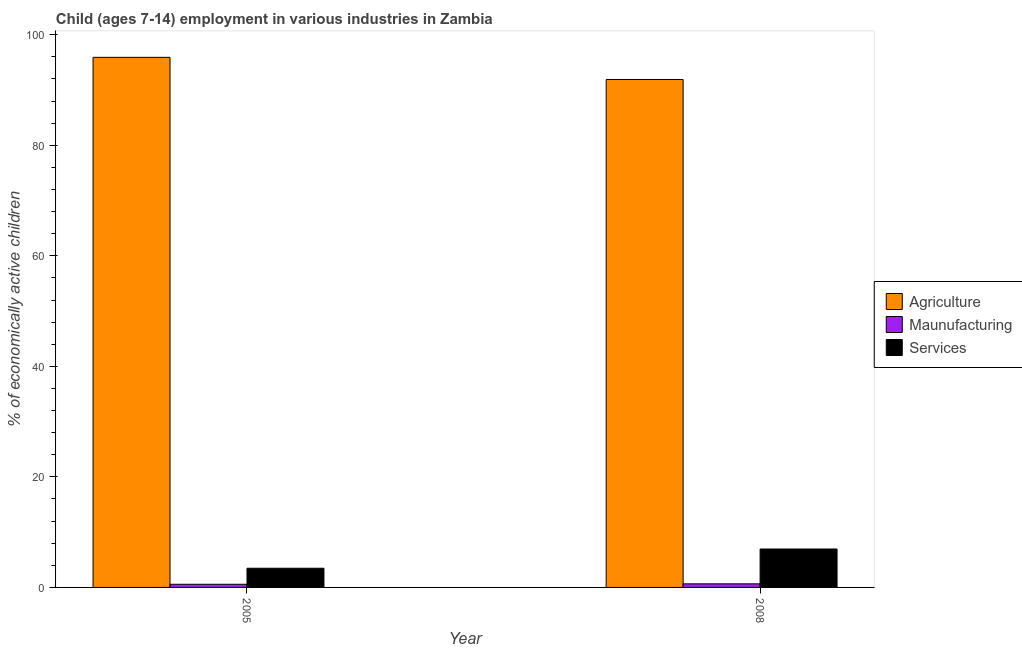How many groups of bars are there?
Offer a terse response. 2. Are the number of bars on each tick of the X-axis equal?
Offer a very short reply. Yes. How many bars are there on the 1st tick from the left?
Keep it short and to the point. 3. How many bars are there on the 2nd tick from the right?
Your answer should be very brief. 3. In how many cases, is the number of bars for a given year not equal to the number of legend labels?
Give a very brief answer. 0. What is the percentage of economically active children in agriculture in 2008?
Your answer should be very brief. 91.9. Across all years, what is the maximum percentage of economically active children in services?
Give a very brief answer. 6.95. Across all years, what is the minimum percentage of economically active children in manufacturing?
Provide a short and direct response. 0.57. In which year was the percentage of economically active children in manufacturing maximum?
Offer a terse response. 2008. In which year was the percentage of economically active children in manufacturing minimum?
Ensure brevity in your answer.  2005. What is the total percentage of economically active children in services in the graph?
Your answer should be very brief. 10.42. What is the difference between the percentage of economically active children in manufacturing in 2005 and that in 2008?
Your response must be concise. -0.08. What is the difference between the percentage of economically active children in services in 2008 and the percentage of economically active children in manufacturing in 2005?
Offer a very short reply. 3.48. What is the average percentage of economically active children in agriculture per year?
Your response must be concise. 93.91. What is the ratio of the percentage of economically active children in services in 2005 to that in 2008?
Provide a succinct answer. 0.5. In how many years, is the percentage of economically active children in services greater than the average percentage of economically active children in services taken over all years?
Provide a short and direct response. 1. What does the 3rd bar from the left in 2008 represents?
Provide a succinct answer. Services. What does the 2nd bar from the right in 2008 represents?
Your response must be concise. Maunufacturing. Does the graph contain any zero values?
Give a very brief answer. No. Does the graph contain grids?
Your answer should be compact. No. Where does the legend appear in the graph?
Your answer should be very brief. Center right. How many legend labels are there?
Keep it short and to the point. 3. What is the title of the graph?
Offer a very short reply. Child (ages 7-14) employment in various industries in Zambia. Does "Methane" appear as one of the legend labels in the graph?
Give a very brief answer. No. What is the label or title of the X-axis?
Make the answer very short. Year. What is the label or title of the Y-axis?
Make the answer very short. % of economically active children. What is the % of economically active children of Agriculture in 2005?
Provide a short and direct response. 95.91. What is the % of economically active children of Maunufacturing in 2005?
Provide a succinct answer. 0.57. What is the % of economically active children in Services in 2005?
Give a very brief answer. 3.47. What is the % of economically active children of Agriculture in 2008?
Your answer should be compact. 91.9. What is the % of economically active children in Maunufacturing in 2008?
Provide a succinct answer. 0.65. What is the % of economically active children of Services in 2008?
Offer a very short reply. 6.95. Across all years, what is the maximum % of economically active children in Agriculture?
Your answer should be very brief. 95.91. Across all years, what is the maximum % of economically active children in Maunufacturing?
Provide a short and direct response. 0.65. Across all years, what is the maximum % of economically active children in Services?
Make the answer very short. 6.95. Across all years, what is the minimum % of economically active children of Agriculture?
Your answer should be compact. 91.9. Across all years, what is the minimum % of economically active children of Maunufacturing?
Ensure brevity in your answer.  0.57. Across all years, what is the minimum % of economically active children of Services?
Your answer should be compact. 3.47. What is the total % of economically active children in Agriculture in the graph?
Offer a terse response. 187.81. What is the total % of economically active children of Maunufacturing in the graph?
Provide a succinct answer. 1.22. What is the total % of economically active children of Services in the graph?
Make the answer very short. 10.42. What is the difference between the % of economically active children in Agriculture in 2005 and that in 2008?
Give a very brief answer. 4.01. What is the difference between the % of economically active children of Maunufacturing in 2005 and that in 2008?
Your answer should be very brief. -0.08. What is the difference between the % of economically active children of Services in 2005 and that in 2008?
Your answer should be compact. -3.48. What is the difference between the % of economically active children in Agriculture in 2005 and the % of economically active children in Maunufacturing in 2008?
Your answer should be very brief. 95.26. What is the difference between the % of economically active children of Agriculture in 2005 and the % of economically active children of Services in 2008?
Your response must be concise. 88.96. What is the difference between the % of economically active children of Maunufacturing in 2005 and the % of economically active children of Services in 2008?
Provide a short and direct response. -6.38. What is the average % of economically active children of Agriculture per year?
Offer a terse response. 93.91. What is the average % of economically active children of Maunufacturing per year?
Offer a terse response. 0.61. What is the average % of economically active children of Services per year?
Your answer should be very brief. 5.21. In the year 2005, what is the difference between the % of economically active children of Agriculture and % of economically active children of Maunufacturing?
Offer a very short reply. 95.34. In the year 2005, what is the difference between the % of economically active children of Agriculture and % of economically active children of Services?
Provide a short and direct response. 92.44. In the year 2005, what is the difference between the % of economically active children of Maunufacturing and % of economically active children of Services?
Offer a very short reply. -2.9. In the year 2008, what is the difference between the % of economically active children in Agriculture and % of economically active children in Maunufacturing?
Offer a terse response. 91.25. In the year 2008, what is the difference between the % of economically active children of Agriculture and % of economically active children of Services?
Provide a succinct answer. 84.95. What is the ratio of the % of economically active children of Agriculture in 2005 to that in 2008?
Provide a short and direct response. 1.04. What is the ratio of the % of economically active children in Maunufacturing in 2005 to that in 2008?
Offer a very short reply. 0.88. What is the ratio of the % of economically active children in Services in 2005 to that in 2008?
Provide a succinct answer. 0.5. What is the difference between the highest and the second highest % of economically active children in Agriculture?
Provide a succinct answer. 4.01. What is the difference between the highest and the second highest % of economically active children of Services?
Your answer should be compact. 3.48. What is the difference between the highest and the lowest % of economically active children in Agriculture?
Your answer should be compact. 4.01. What is the difference between the highest and the lowest % of economically active children in Services?
Your response must be concise. 3.48. 